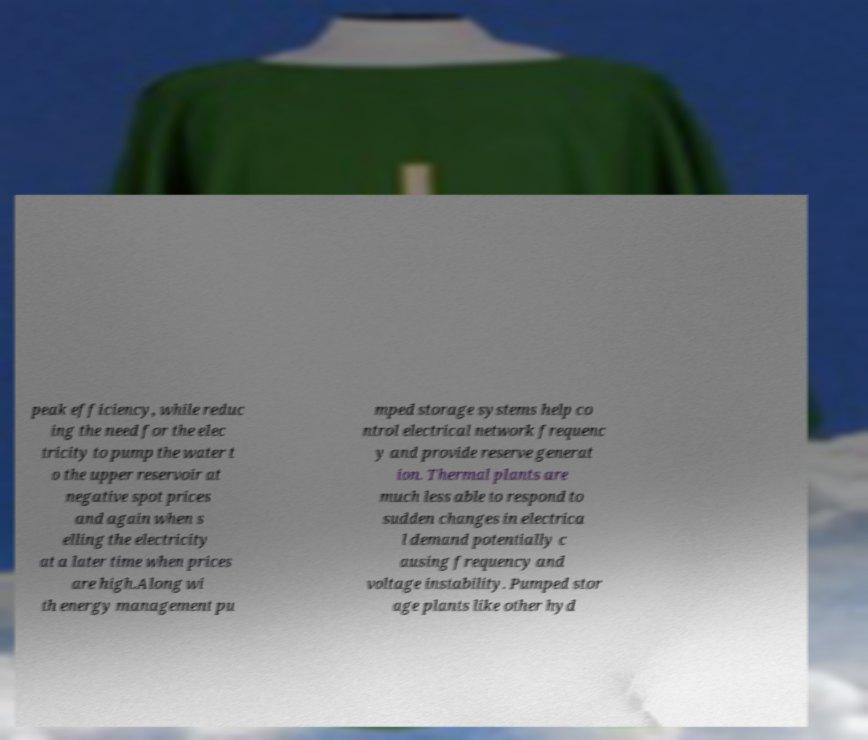Could you extract and type out the text from this image? peak efficiency, while reduc ing the need for the elec tricity to pump the water t o the upper reservoir at negative spot prices and again when s elling the electricity at a later time when prices are high.Along wi th energy management pu mped storage systems help co ntrol electrical network frequenc y and provide reserve generat ion. Thermal plants are much less able to respond to sudden changes in electrica l demand potentially c ausing frequency and voltage instability. Pumped stor age plants like other hyd 